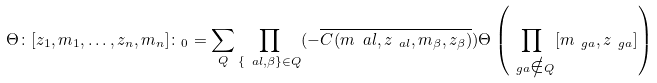<formula> <loc_0><loc_0><loc_500><loc_500>\Theta \colon [ z _ { 1 } , m _ { 1 } , \dots , z _ { n } , m _ { n } ] \colon _ { 0 } = \sum _ { Q } \prod _ { \{ \ a l , \beta \} \in Q } ( - \overline { C ( m _ { \ } a l , z _ { \ a l } , m _ { \beta } , z _ { \beta } ) } ) \Theta \left ( \prod _ { \ g a \notin Q } [ m _ { \ g a } , z _ { \ g a } ] \right )</formula> 